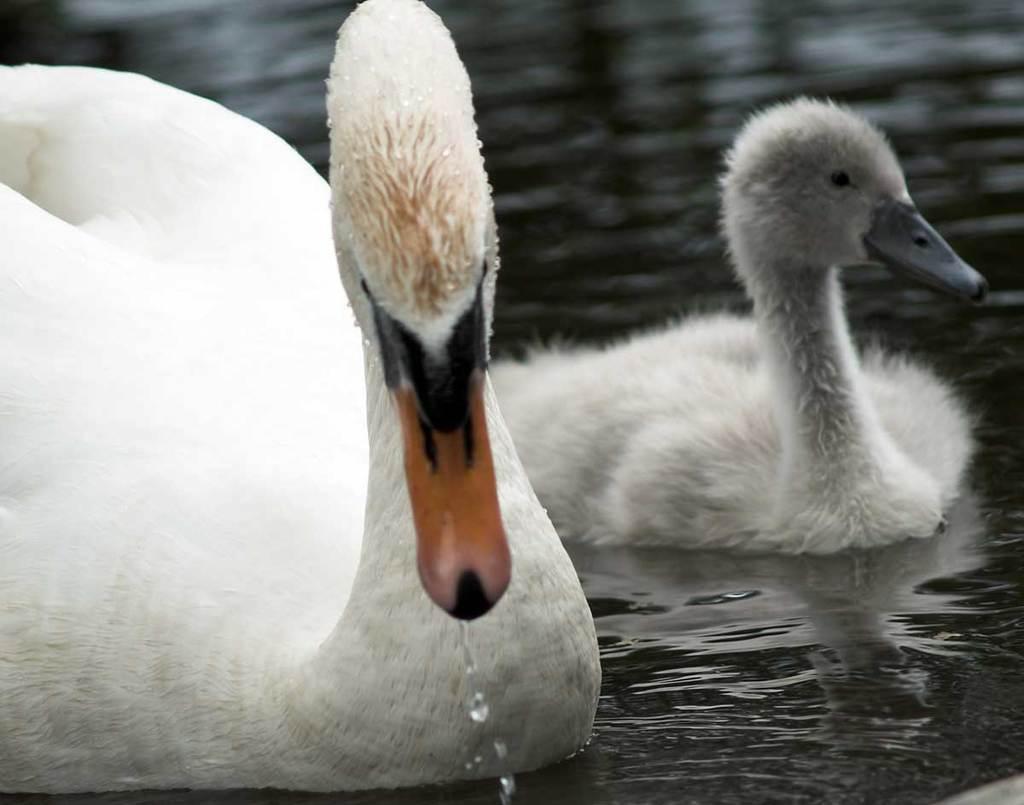Can you describe this image briefly? In the picture we can see two ducks in the water, which are white in color one with an orange color beak and one is with a gray color beak. 